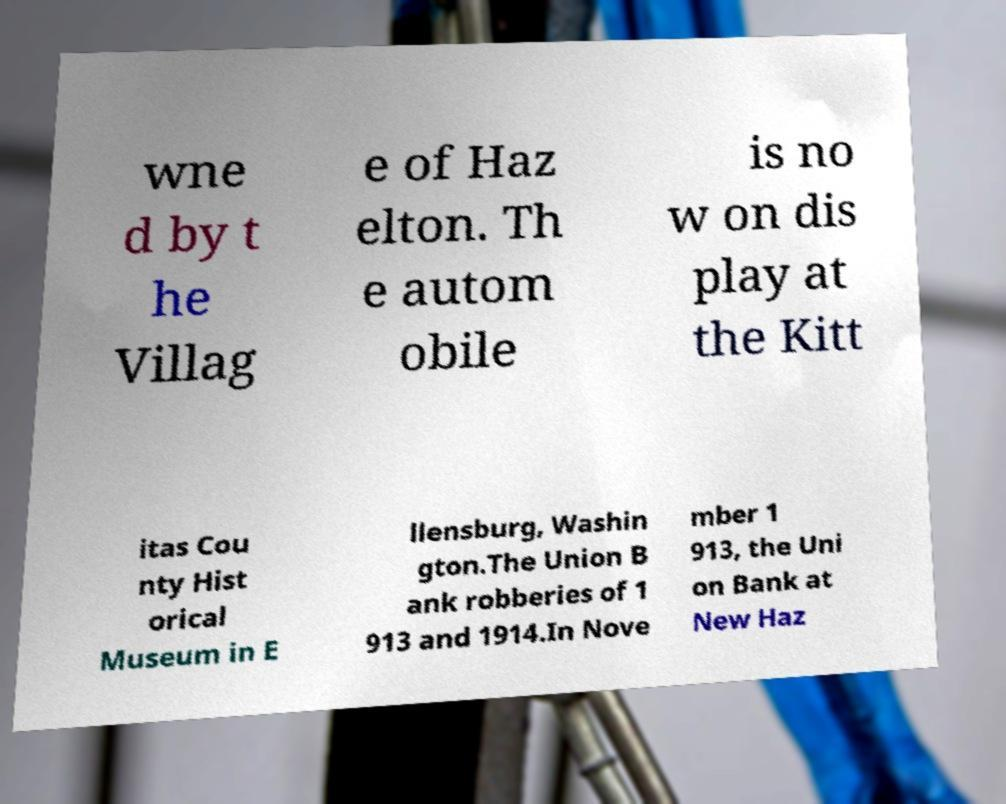Could you assist in decoding the text presented in this image and type it out clearly? wne d by t he Villag e of Haz elton. Th e autom obile is no w on dis play at the Kitt itas Cou nty Hist orical Museum in E llensburg, Washin gton.The Union B ank robberies of 1 913 and 1914.In Nove mber 1 913, the Uni on Bank at New Haz 